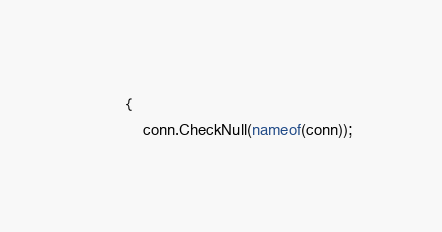<code> <loc_0><loc_0><loc_500><loc_500><_C#_>        {
            conn.CheckNull(nameof(conn));</code> 